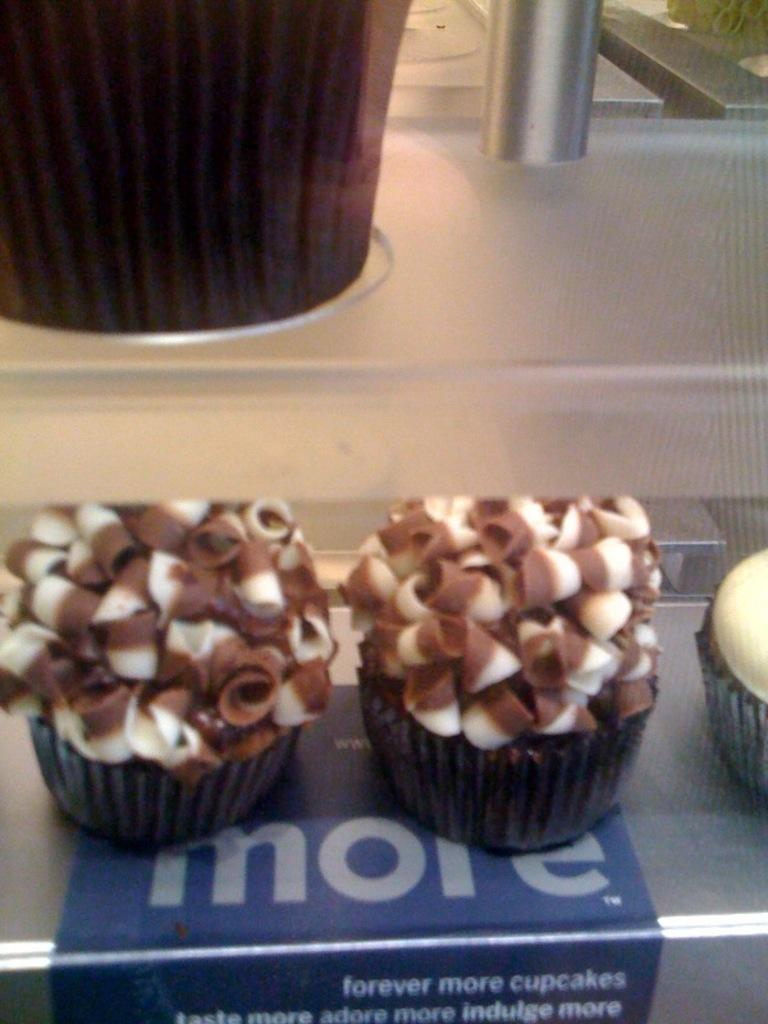What is the main piece of furniture in the image? There is a table in the image. What type of food is on the table? There are cupcakes on the table. What type of magic is being performed with the calculator in the image? There is no calculator or magic present in the image; it only features a table with cupcakes. 